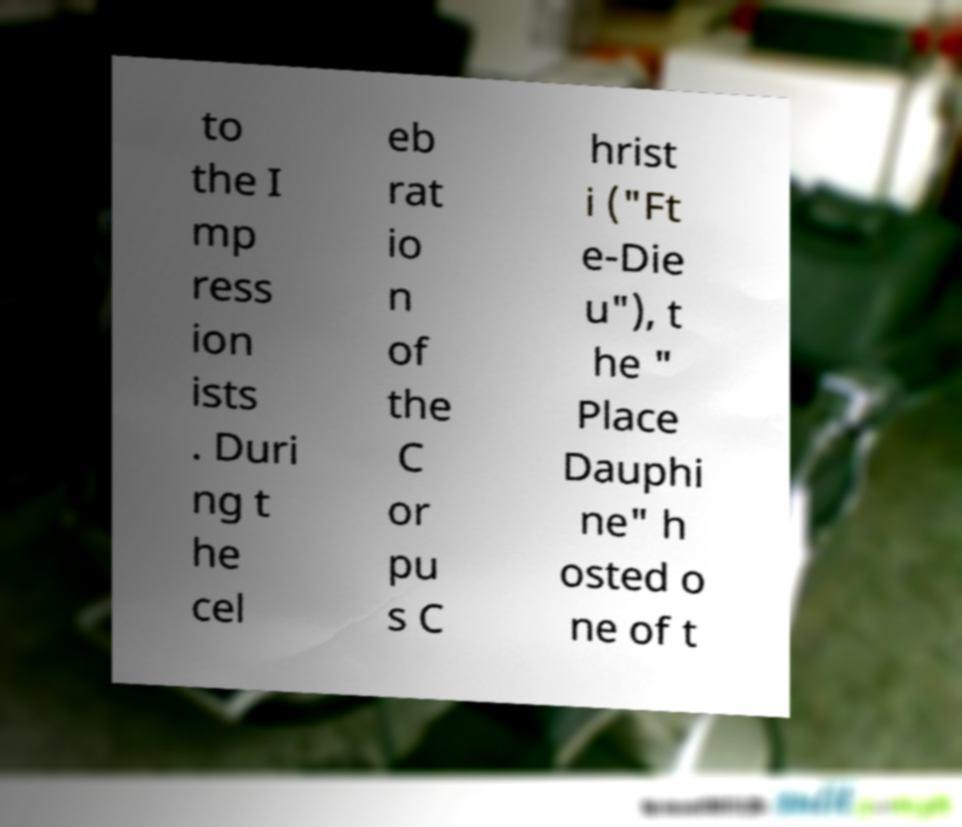For documentation purposes, I need the text within this image transcribed. Could you provide that? to the I mp ress ion ists . Duri ng t he cel eb rat io n of the C or pu s C hrist i ("Ft e-Die u"), t he " Place Dauphi ne" h osted o ne of t 